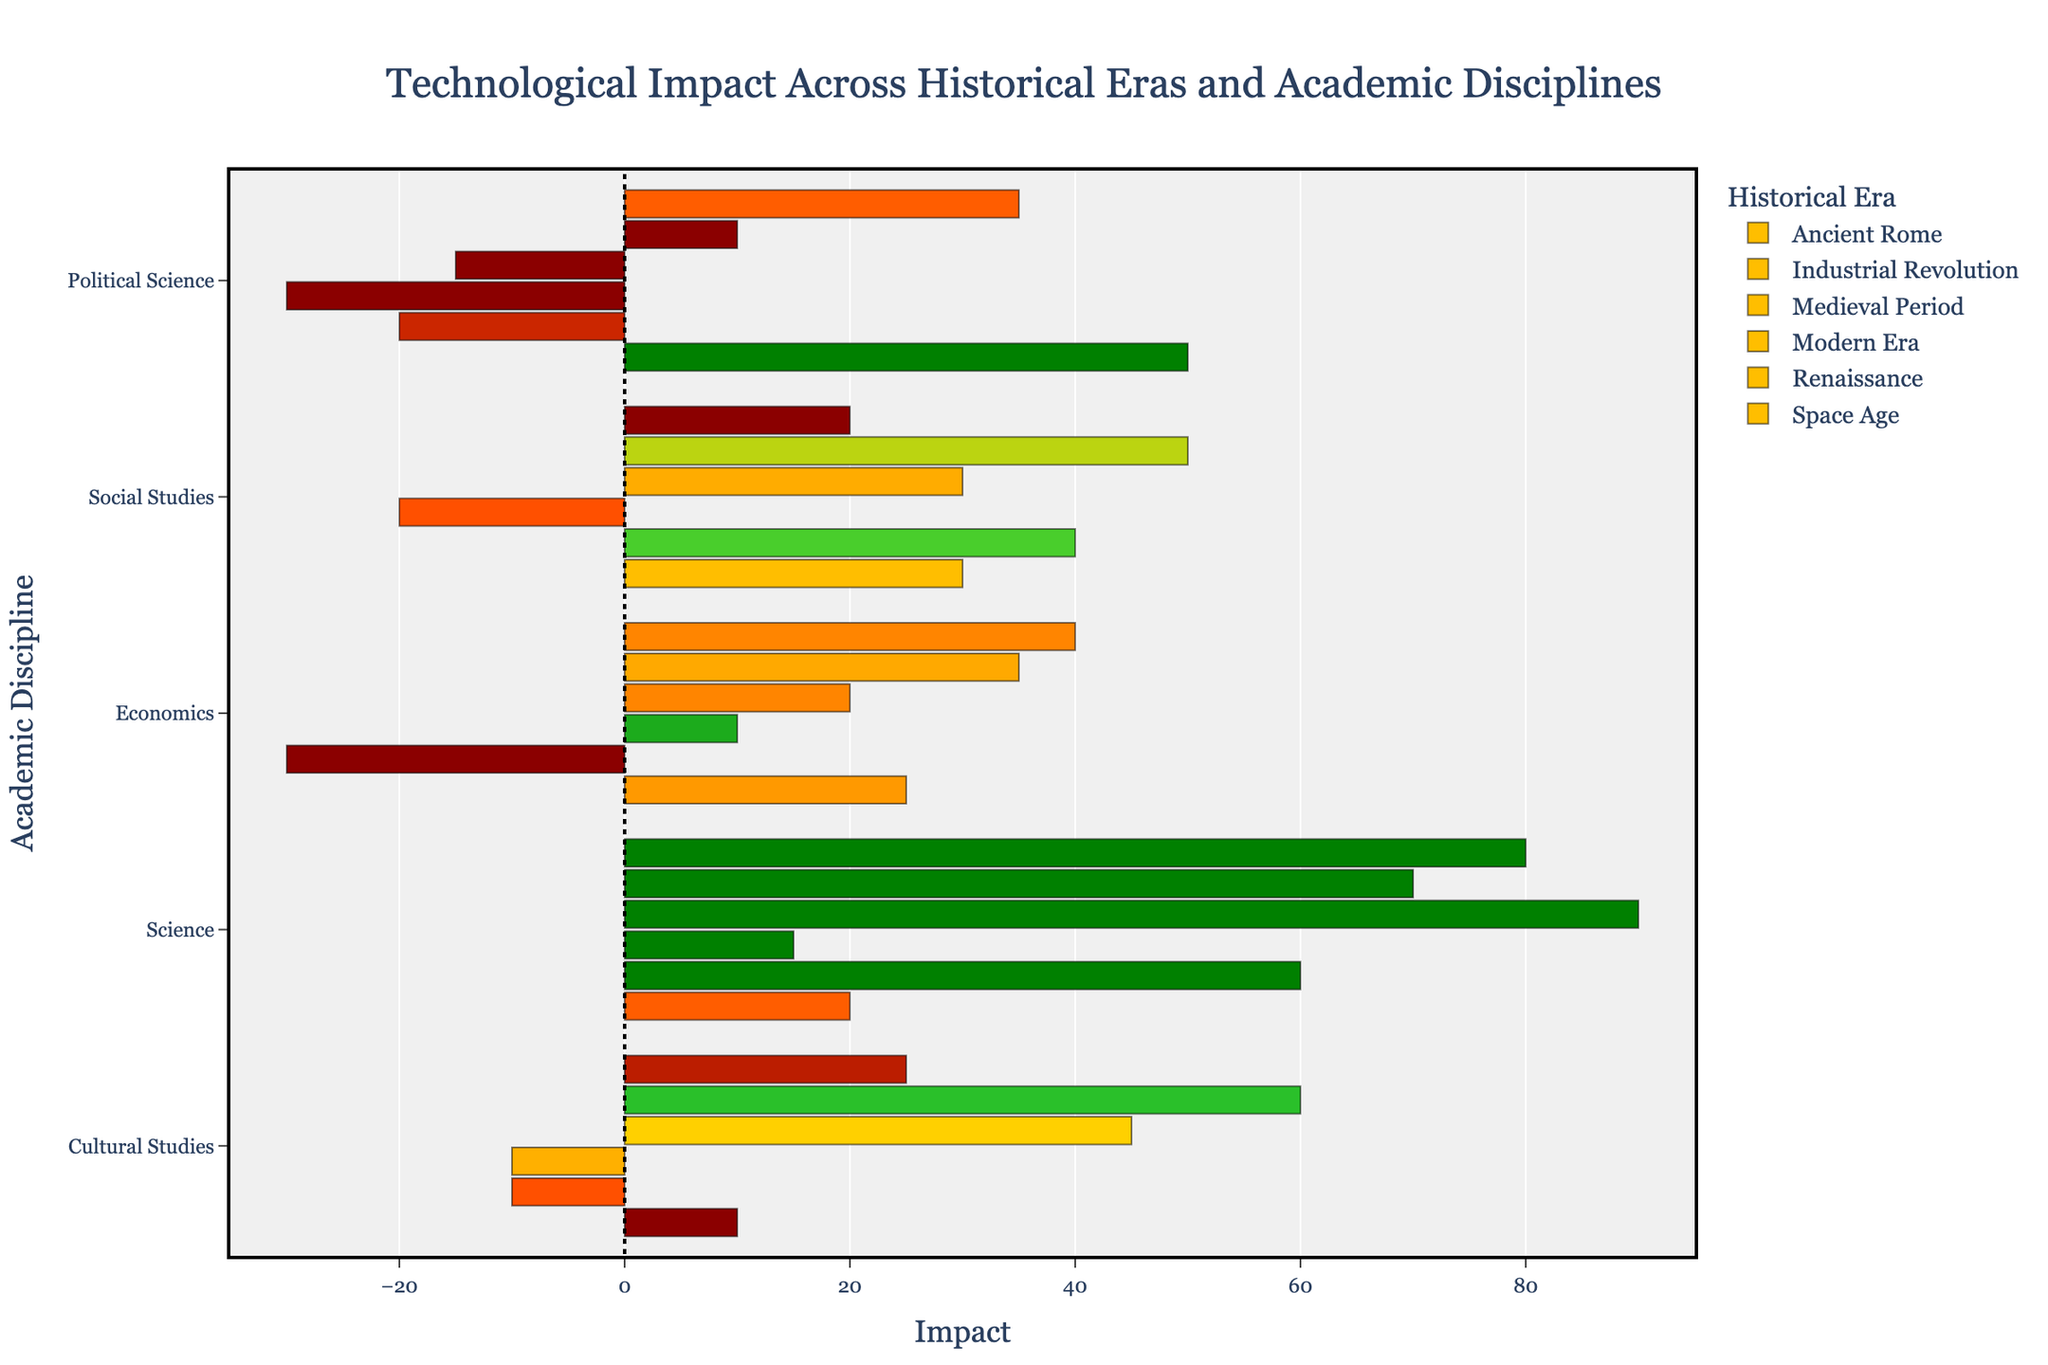What is the average impact of the Industrial Revolution across all academic disciplines? To find the average impact for the Industrial Revolution, sum up the impacts for each discipline and then divide by the number of disciplines. The impacts are -30, 40, -20, 60, -10. Sum = (-30 + 40 - 20 + 60 - 10) = 40. There are 5 disciplines, so the average impact is 40 / 5 = 8
Answer: 8 Which academic discipline has the highest positive impact during the Renaissance era? To find the highest positive impact, check the Impact values for all disciplines in the Renaissance era and select the maximum value. The impacts are 35, 50, 10, 70, 60. The highest positive impact is 70 (Science)
Answer: Science What is the total impact of technological advancements in Political Science across all eras? To find the total impact in Political Science, sum the impact values in Political Science across all eras. The impacts are -20 (Industrial Revolution), 10 (Renaissance), -15 (Modern Era), 50 (Ancient Rome), -30 (Medieval Period), and 35 (Space Age). The total is -20 + 10 - 15 + 50 - 30 + 35 = 30
Answer: 30 Which era has the largest range of impacts (difference between the highest and lowest impact) in Science? To find the largest range of impacts, calculate the difference between the highest and lowest impacts in Science for each era and identify the maximum range. Industrial Revolution: 60, Renaissance: 70, Modern Era: 90, Ancient Rome: 20, Medieval Period: 15, Space Age: 80. Hence, the ranges are: IR = 60-60=0, R = 70-70=0, ME = 90-90=0, AR = 20-20=0, MP = 15-15=0, SA = 80-80=0. Since all are the same, the range is consistently 0. Note that each era for Science has a single value that repeats.
Answer: All eras have the same range = 0 Which academic discipline shows the greatest variation in impact across all eras? To find the discipline with the greatest variation, calculate the range of impacts (difference between max and min impact) for each discipline across all eras. Here are the results:
Economics: Max = 40 (Space Age), Min = 10 (Medieval Period), Range = 40 - 10 = 30
Social Studies: Max = 50 (Renaissance), Min = -20 (Medieval Period), Range = 50 - (-20) = 70
Political Science: Max = 50 (Ancient Rome), Min = -30 (Medieval Period), Range = 50 - (-30) = 80
Science: Max = 90 (Modern Era), Min = 15 (Medieval Period), Range = 90 - 15 = 75
Cultural Studies: Max = 60 (Renaissance), Min = -10 (Industrial Revolution, Medieval Period), Range = 60 - (-10) = 70
The greatest variation is in Political Science with a range of 80.
Answer: Political Science How does the impact of technological advancements during the Modern Era in Science compare to the Cultural Studies? To compare, look at the impact values for Science and Cultural Studies in the Modern Era. Science has an impact of 90, and Cultural Studies has an impact of 45. Since 90 is greater than 45, Science has a higher impact.
Answer: Science has a higher impact than Cultural Studies Which era has the most uniformly distributed impact values across different academic disciplines? To find the most uniformly distributed impact values, look for the era with the smallest range (difference between highest and lowest impacts). Summarize ranges:
Industrial Revolution: 60 - (-30) = 90
Renaissance: 70 - 10 = 60 
Modern Era: 90 - (-15) = 105
Ancient Rome: 50 - 10 = 40
Medieval Period: 15 - (-30) = 45
Space Age: 80 - 20 = 60
Ancient Rome has the smallest range of 40.
Answer: Ancient Rome Which academic discipline has mixed sentiments (both positive and negative impacts) about the Industrial Revolution? Look at each discipline's sentiment values during the Industrial Revolution. Economics: -30 (Concerns), Social Studies: 40 (Positive), Political Science: -20 (Fears), Science: 60 (Positive), Cultural Studies: -10 (Resistance). Only Economics and Political Science have negative impacts, others are positive. So, there’s no mixed sentiment in a single discipline, except for Political Science, considering other eras sentiment varies.
Answer: Political Science 